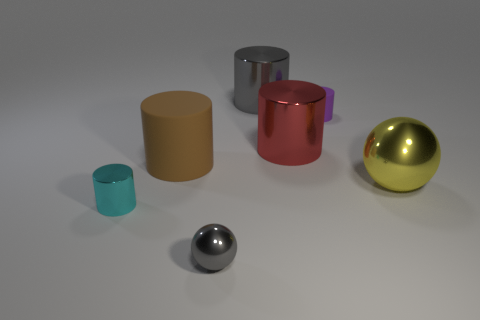What material is the purple thing that is the same shape as the large red object?
Give a very brief answer. Rubber. Do the shiny ball behind the gray metallic ball and the red metal object have the same size?
Keep it short and to the point. Yes. How many matte objects are either cyan things or big yellow balls?
Provide a short and direct response. 0. There is a object that is left of the large gray thing and behind the small cyan object; what is it made of?
Provide a short and direct response. Rubber. Is the material of the big yellow object the same as the tiny gray object?
Keep it short and to the point. Yes. There is a shiny thing that is on the right side of the brown cylinder and left of the large gray thing; what size is it?
Provide a succinct answer. Small. The purple matte object is what shape?
Provide a succinct answer. Cylinder. What number of objects are either tiny shiny objects or big cylinders that are behind the tiny matte thing?
Give a very brief answer. 3. Does the sphere that is in front of the tiny cyan cylinder have the same color as the large rubber object?
Your answer should be very brief. No. The cylinder that is on the left side of the large red thing and behind the red object is what color?
Ensure brevity in your answer.  Gray. 